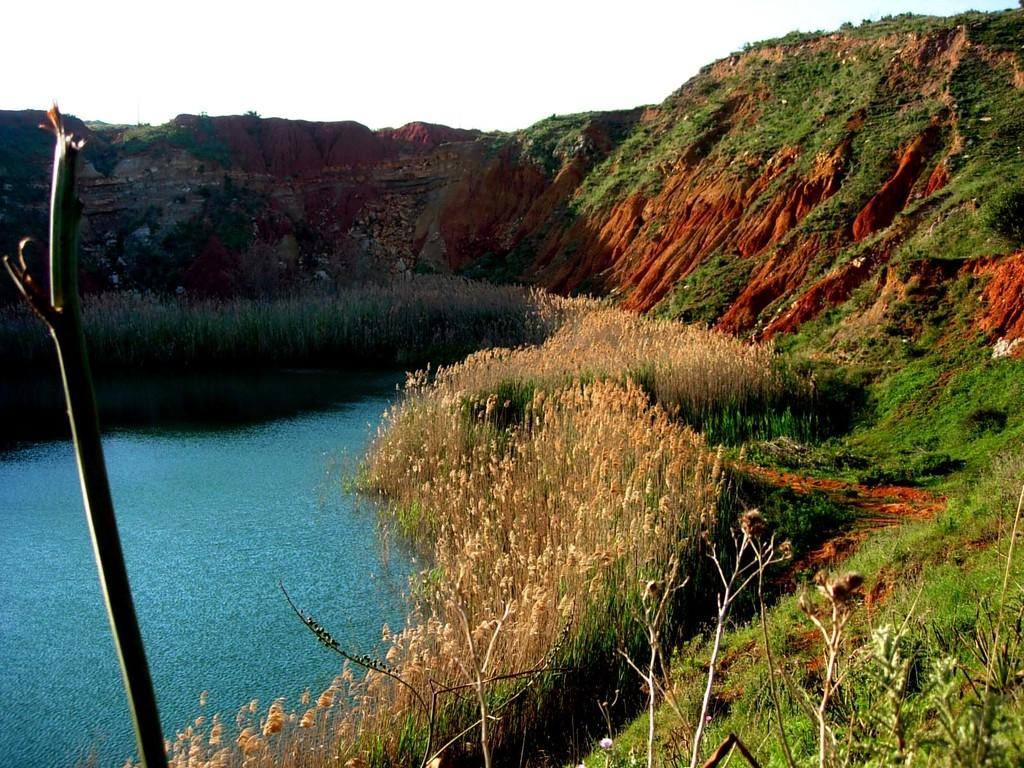What is the main feature of the image? The main feature of the image is a water surface. What can be seen around the water surface? There are plants and greenery around the water surface. Is there any elevated land visible in the image? Yes, there is a small mountain in the image. What language is being spoken by the coach in the image? There is no coach or spoken language present in the image. The image features a water surface, plants, greenery, and a small mountain. 